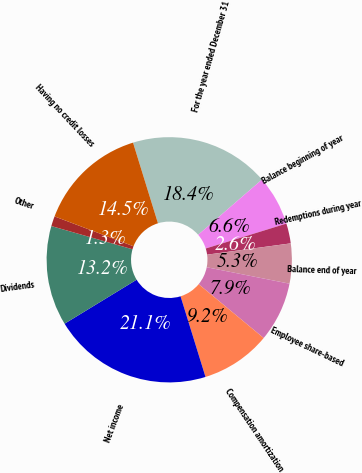<chart> <loc_0><loc_0><loc_500><loc_500><pie_chart><fcel>For the year ended December 31<fcel>Balance beginning of year<fcel>Redemptions during year<fcel>Balance end of year<fcel>Employee share-based<fcel>Compensation amortization<fcel>Net income<fcel>Dividends<fcel>Other<fcel>Having no credit losses<nl><fcel>18.42%<fcel>6.58%<fcel>2.63%<fcel>5.26%<fcel>7.89%<fcel>9.21%<fcel>21.05%<fcel>13.16%<fcel>1.32%<fcel>14.47%<nl></chart> 